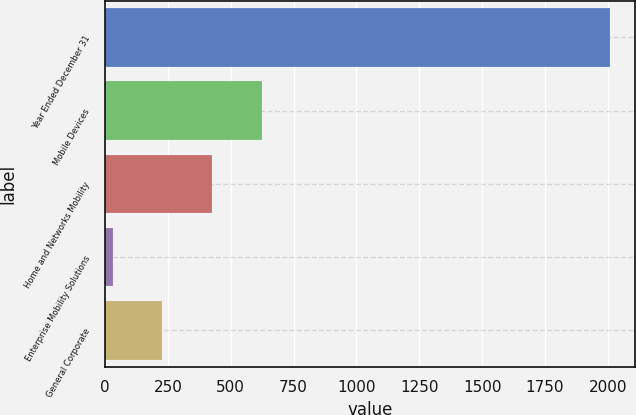Convert chart to OTSL. <chart><loc_0><loc_0><loc_500><loc_500><bar_chart><fcel>Year Ended December 31<fcel>Mobile Devices<fcel>Home and Networks Mobility<fcel>Enterprise Mobility Solutions<fcel>General Corporate<nl><fcel>2007<fcel>623.1<fcel>425.4<fcel>30<fcel>227.7<nl></chart> 